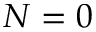<formula> <loc_0><loc_0><loc_500><loc_500>N = 0</formula> 